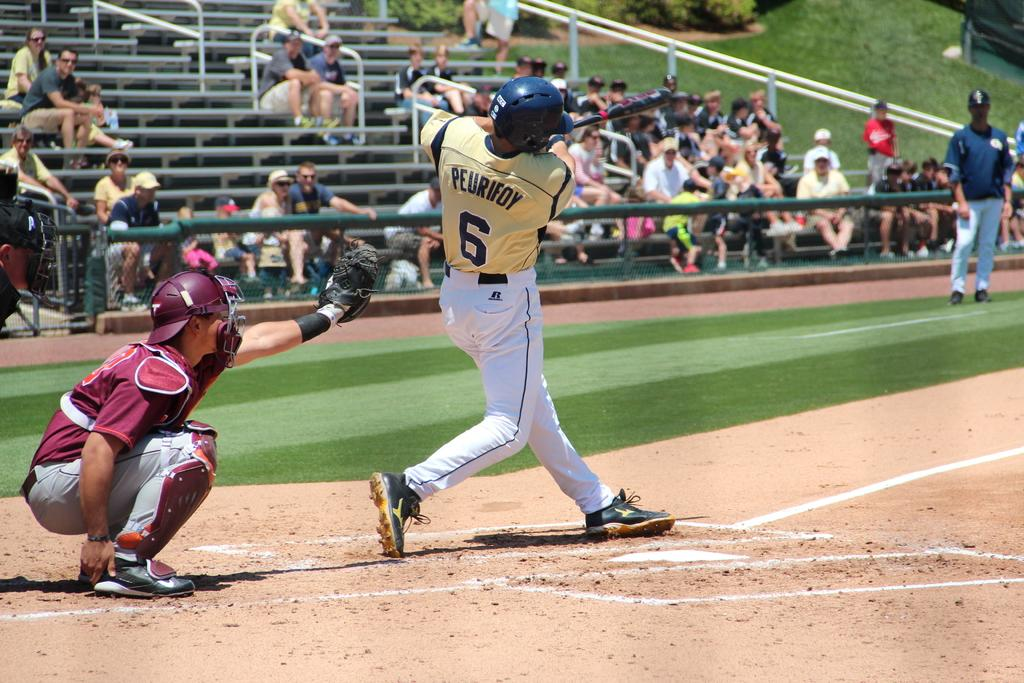<image>
Relay a brief, clear account of the picture shown. A batter named Peurifoy takes a swing at the ball as a few people watch from the sparsely populated stands. 